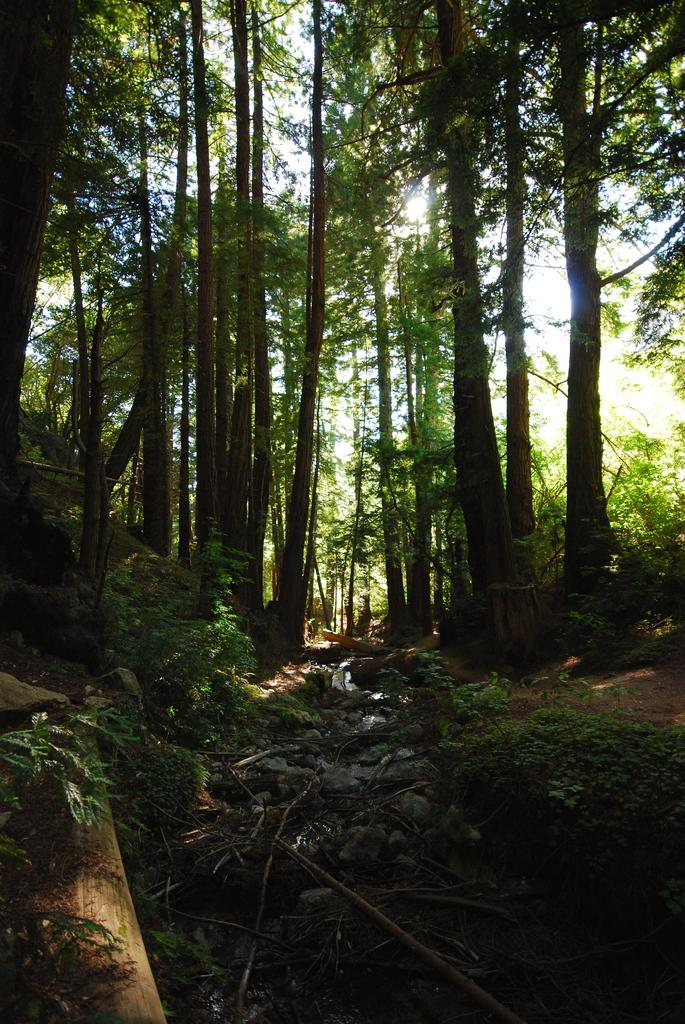What type of vegetation can be seen in the image? There are trees and plants visible in the image. What is visible at the top of the image? The sky is visible at the top of the image. What type of objects are present at the bottom of the image? Stones and sticks are present at the bottom of the image. What color is the dress worn by the earth in the image? There is no dress or earth present in the image; it features trees, plants, sky, stones, and sticks. 